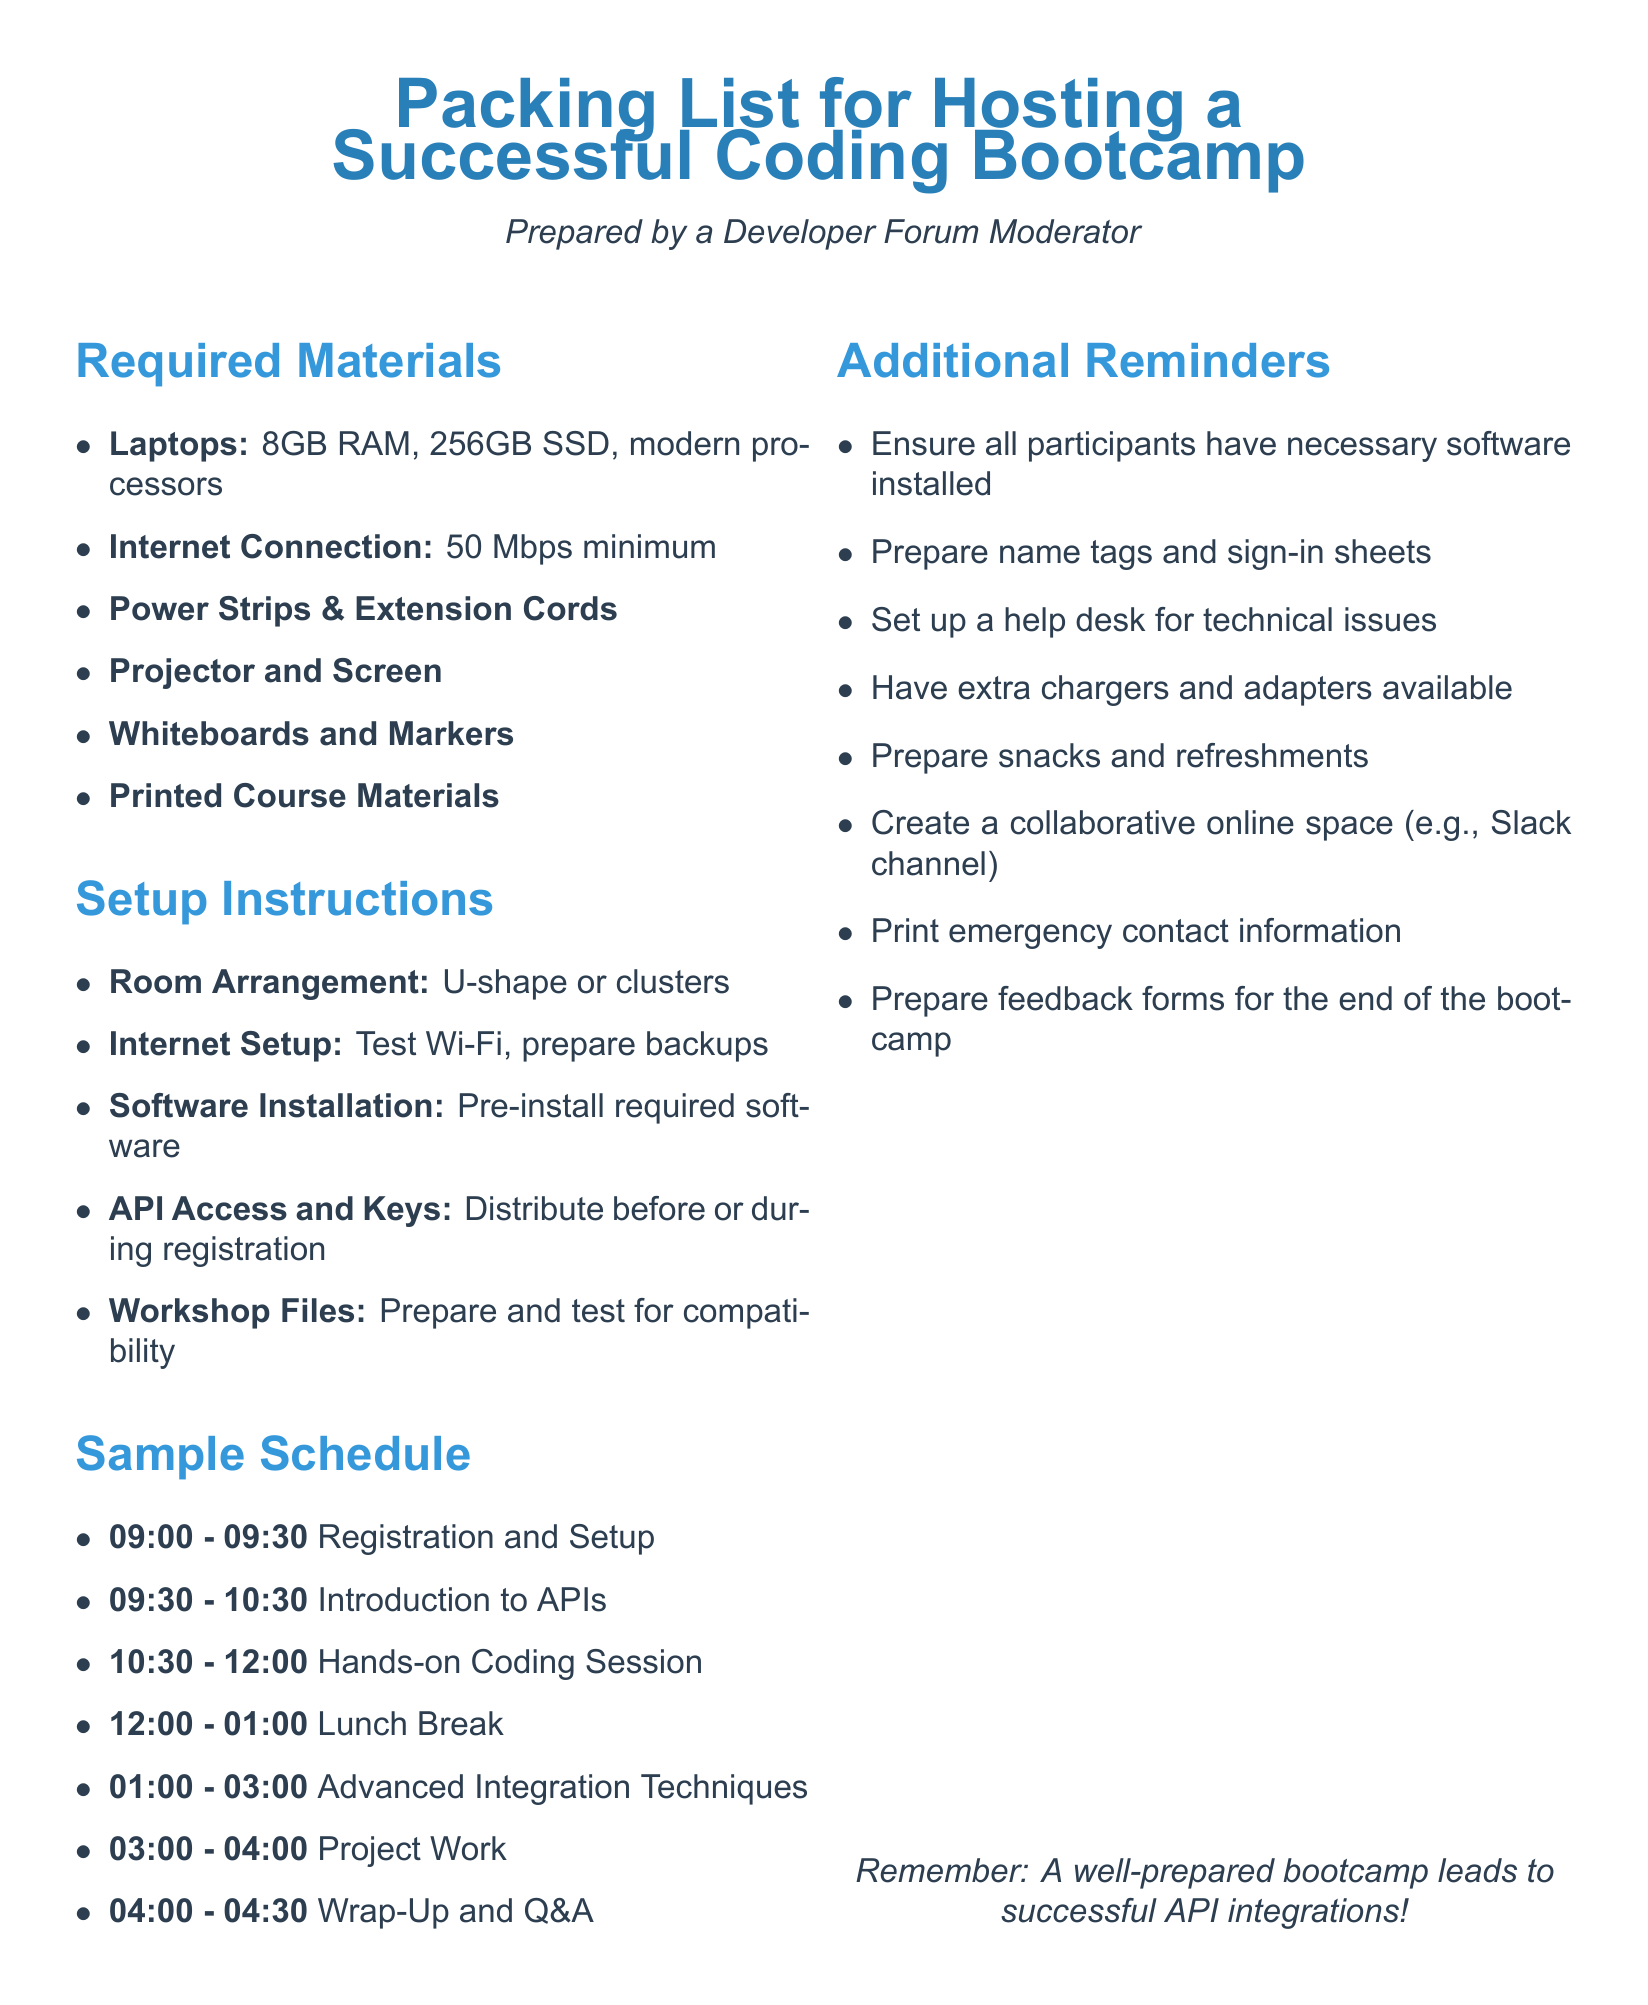What is the minimum required internet speed? The document states that a minimum internet connection of 50 Mbps is required for the bootcamp.
Answer: 50 Mbps How many laptops are needed? The document does not specify the number of laptops, but it states the required specifications for them.
Answer: Not specified What is the first activity scheduled? The first activity listed in the sample schedule is Registration and Setup, which takes place from 09:00 to 09:30.
Answer: Registration and Setup What type of room arrangement is suggested? The suggested room arrangement for the bootcamp is either U-shape or clusters to facilitate interaction among participants.
Answer: U-shape or clusters What should participants receive before or during registration? The document mentions that API Access and Keys should be distributed before or during registration to participants.
Answer: API Access and Keys What is an additional reminder related to software? One of the additional reminders emphasizes ensuring all participants have the necessary software installed prior to the bootcamp.
Answer: Necessary software installed How long is the lunch break scheduled for? The lunch break is scheduled for one hour, from 12:00 to 01:00.
Answer: One hour What is the last activity of the day? The last activity mentioned in the sample schedule is Wrap-Up and Q&A, taking place from 04:00 to 04:30.
Answer: Wrap-Up and Q&A What item is suggested for technical issues? A help desk is recommended to assist participants with any technical issues that may arise during the bootcamp.
Answer: Help desk 